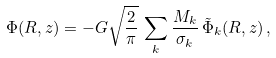<formula> <loc_0><loc_0><loc_500><loc_500>\Phi ( R , z ) = - G \sqrt { \frac { 2 } { \pi } } \, \sum _ { k } \frac { M _ { k } } { \sigma _ { k } } \, \tilde { \Phi } _ { k } ( R , z ) \, ,</formula> 